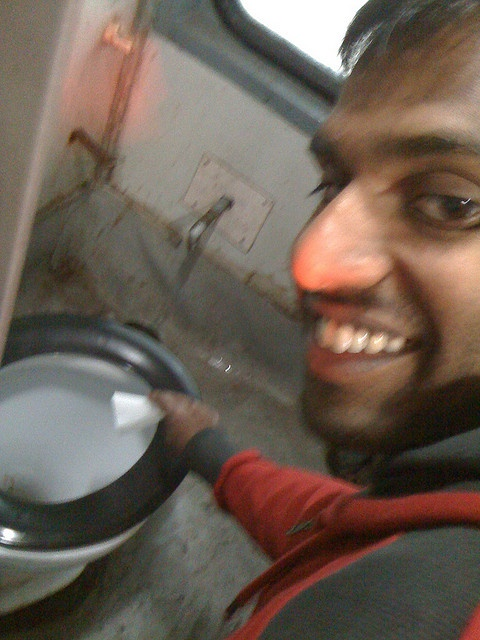Describe the objects in this image and their specific colors. I can see people in gray, black, and maroon tones and toilet in gray, black, darkgray, and darkgreen tones in this image. 